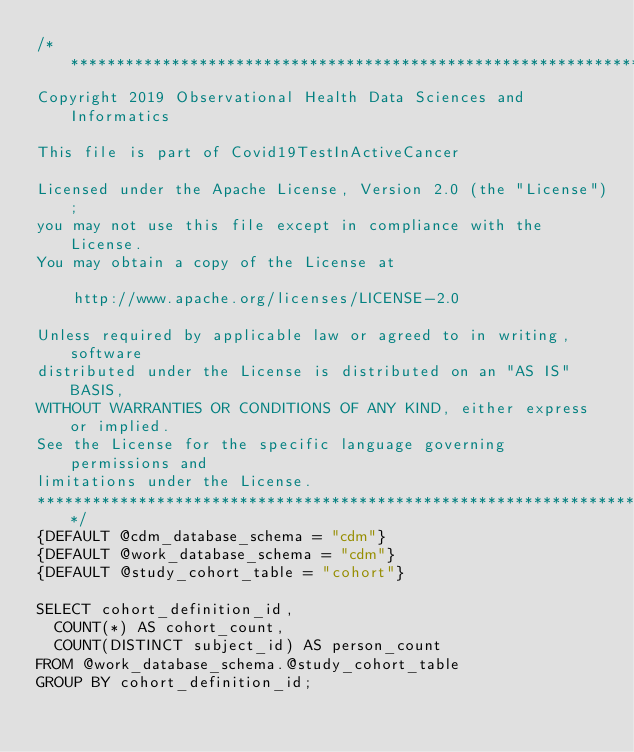Convert code to text. <code><loc_0><loc_0><loc_500><loc_500><_SQL_>/************************************************************************
Copyright 2019 Observational Health Data Sciences and Informatics

This file is part of Covid19TestInActiveCancer

Licensed under the Apache License, Version 2.0 (the "License");
you may not use this file except in compliance with the License.
You may obtain a copy of the License at

    http://www.apache.org/licenses/LICENSE-2.0

Unless required by applicable law or agreed to in writing, software
distributed under the License is distributed on an "AS IS" BASIS,
WITHOUT WARRANTIES OR CONDITIONS OF ANY KIND, either express or implied.
See the License for the specific language governing permissions and
limitations under the License.
************************************************************************/
{DEFAULT @cdm_database_schema = "cdm"}
{DEFAULT @work_database_schema = "cdm"}
{DEFAULT @study_cohort_table = "cohort"}

SELECT cohort_definition_id,
	COUNT(*) AS cohort_count,
	COUNT(DISTINCT subject_id) AS person_count
FROM @work_database_schema.@study_cohort_table
GROUP BY cohort_definition_id;
</code> 